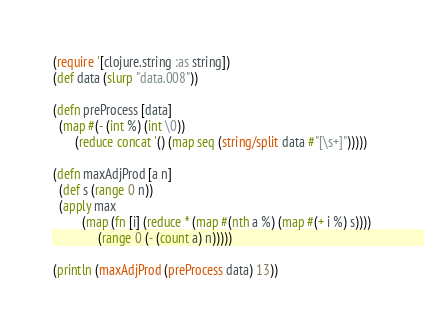Convert code to text. <code><loc_0><loc_0><loc_500><loc_500><_Clojure_>(require '[clojure.string :as string])
(def data (slurp "data.008"))

(defn preProcess [data]
  (map #(- (int %) (int \0))
       (reduce concat '() (map seq (string/split data #"[\s+]")))))

(defn maxAdjProd [a n]
  (def s (range 0 n))
  (apply max
         (map (fn [i] (reduce * (map #(nth a %) (map #(+ i %) s))))
              (range 0 (- (count a) n)))))

(println (maxAdjProd (preProcess data) 13))
</code> 